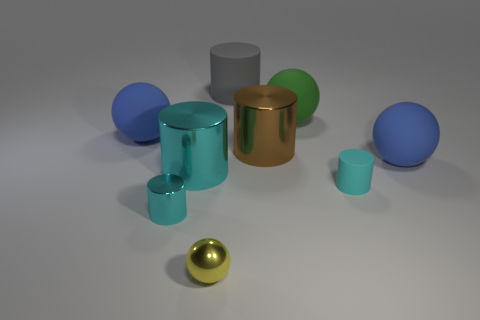Subtract all rubber balls. How many balls are left? 1 Subtract all brown blocks. How many cyan cylinders are left? 3 Add 1 brown cylinders. How many objects exist? 10 Subtract all yellow spheres. How many spheres are left? 3 Subtract 2 balls. How many balls are left? 2 Subtract all balls. How many objects are left? 5 Subtract all green spheres. Subtract all yellow cylinders. How many spheres are left? 3 Subtract all big brown metal blocks. Subtract all big gray cylinders. How many objects are left? 8 Add 2 cyan cylinders. How many cyan cylinders are left? 5 Add 6 large matte cylinders. How many large matte cylinders exist? 7 